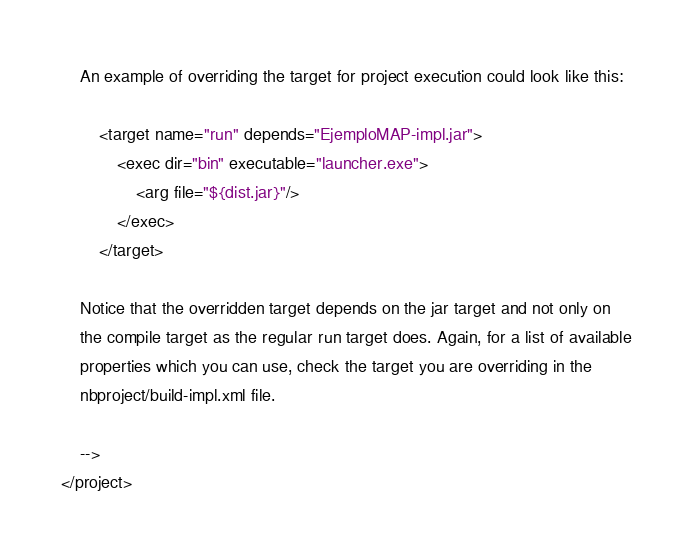Convert code to text. <code><loc_0><loc_0><loc_500><loc_500><_XML_>    An example of overriding the target for project execution could look like this:

        <target name="run" depends="EjemploMAP-impl.jar">
            <exec dir="bin" executable="launcher.exe">
                <arg file="${dist.jar}"/>
            </exec>
        </target>

    Notice that the overridden target depends on the jar target and not only on 
    the compile target as the regular run target does. Again, for a list of available 
    properties which you can use, check the target you are overriding in the
    nbproject/build-impl.xml file. 

    -->
</project>
</code> 